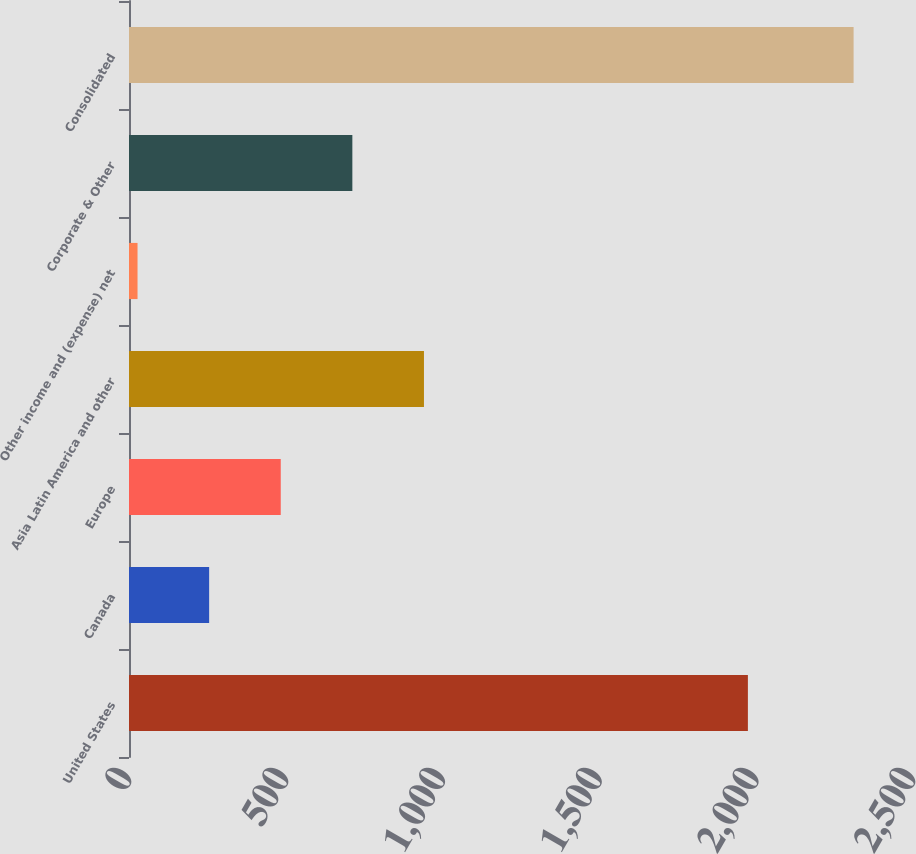Convert chart. <chart><loc_0><loc_0><loc_500><loc_500><bar_chart><fcel>United States<fcel>Canada<fcel>Europe<fcel>Asia Latin America and other<fcel>Other income and (expense) net<fcel>Corporate & Other<fcel>Consolidated<nl><fcel>1973.5<fcel>255.54<fcel>483.88<fcel>940.56<fcel>27.2<fcel>712.22<fcel>2310.6<nl></chart> 